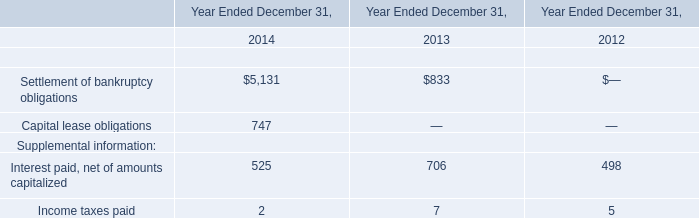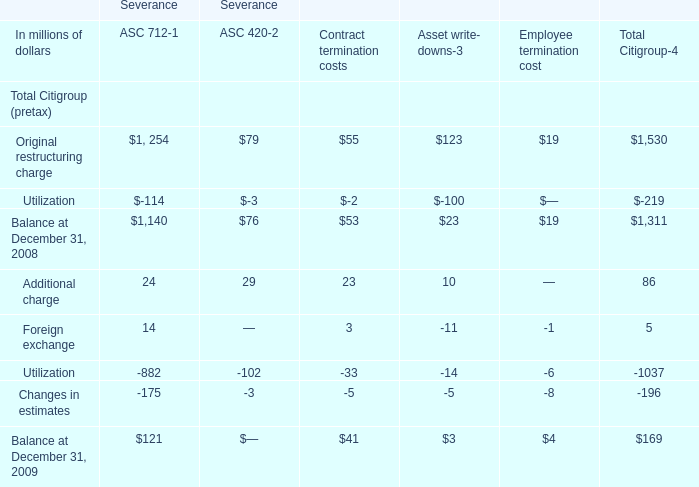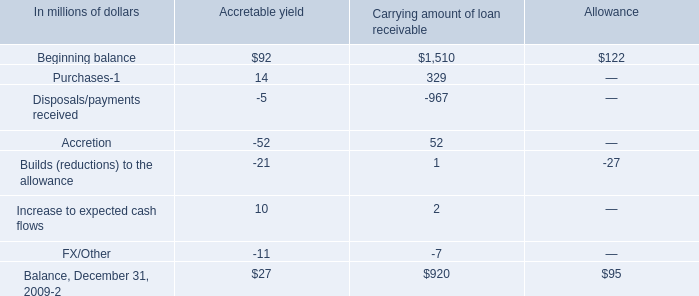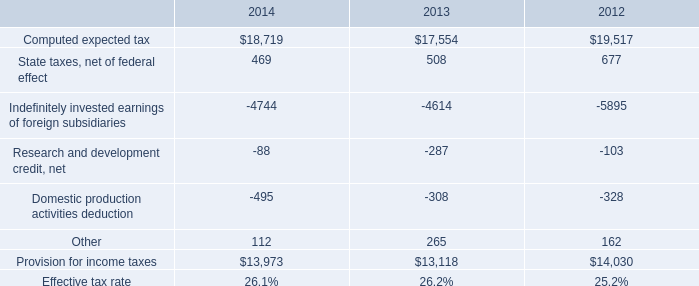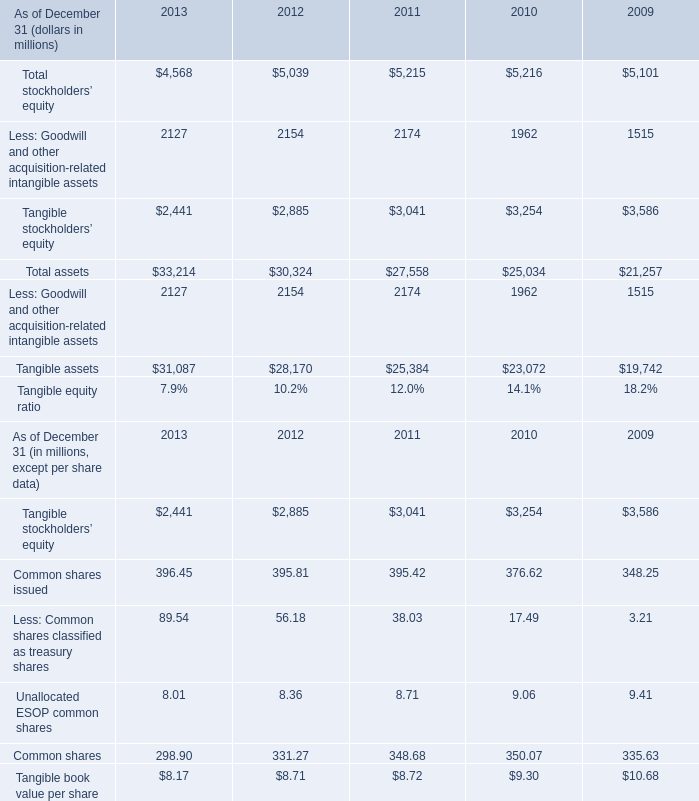What is the average amount of Tangible stockholders’ equity of 2012, and Provision for income taxes of 2012 ? 
Computations: ((2885.0 + 14030.0) / 2)
Answer: 8457.5. 